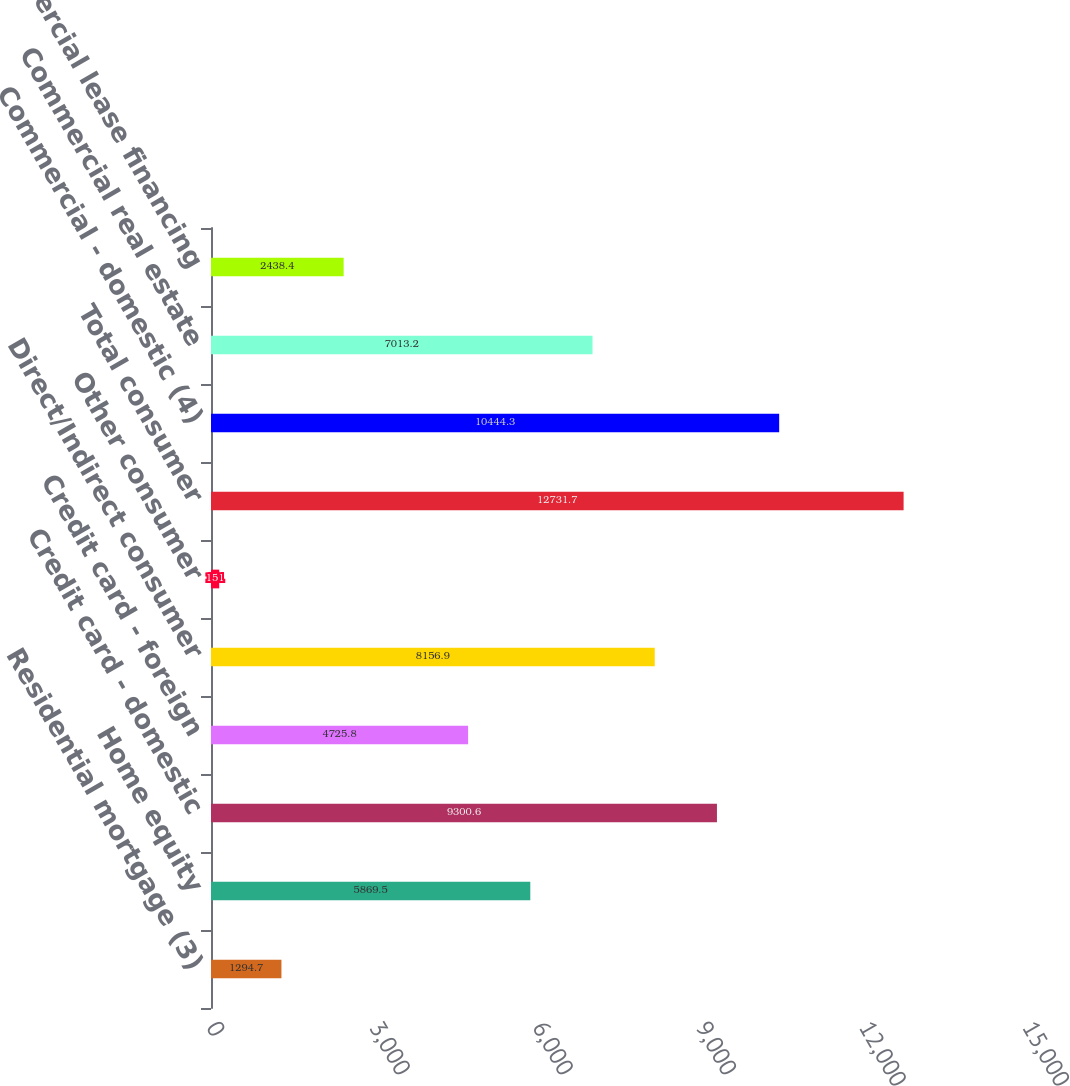Convert chart to OTSL. <chart><loc_0><loc_0><loc_500><loc_500><bar_chart><fcel>Residential mortgage (3)<fcel>Home equity<fcel>Credit card - domestic<fcel>Credit card - foreign<fcel>Direct/Indirect consumer<fcel>Other consumer<fcel>Total consumer<fcel>Commercial - domestic (4)<fcel>Commercial real estate<fcel>Commercial lease financing<nl><fcel>1294.7<fcel>5869.5<fcel>9300.6<fcel>4725.8<fcel>8156.9<fcel>151<fcel>12731.7<fcel>10444.3<fcel>7013.2<fcel>2438.4<nl></chart> 